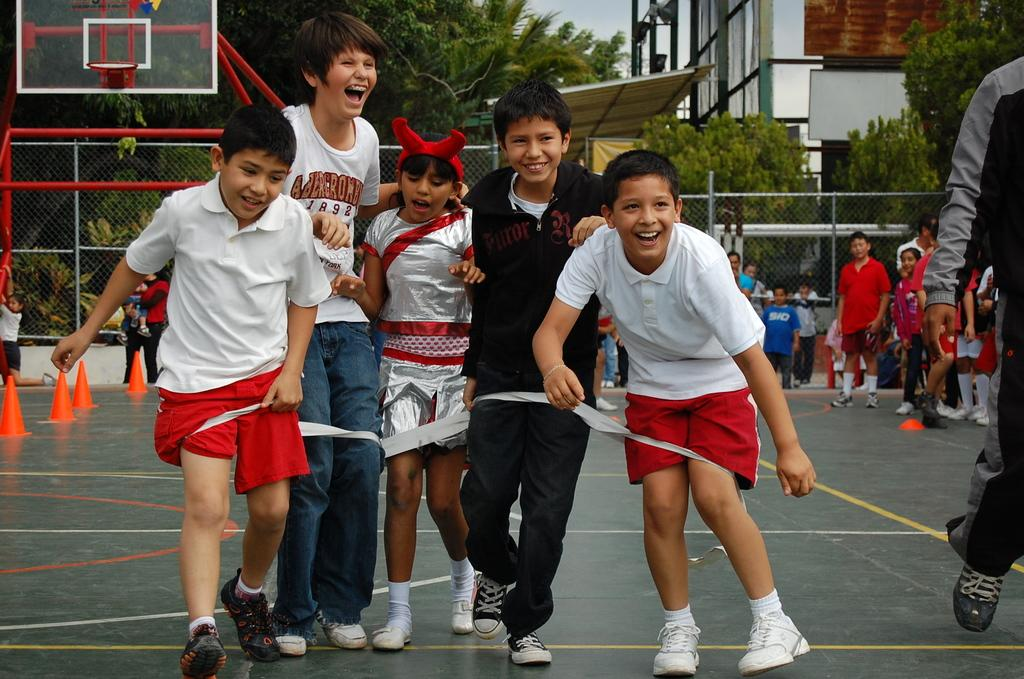What is the main subject of the image? The main subject of the image is a group of people. What are the people wearing in the image? The people are wearing basketball coats in the image. What is the facial expression of the people in the image? The people are smiling in the image. Can you describe the people behind the main group? There are other people standing behind the group in the image. What can be seen in the background of the image? Trees and buildings are visible in the background of the image. What type of thunder can be heard in the image? There is no sound present in the image, so it is not possible to determine if there is any thunder. 